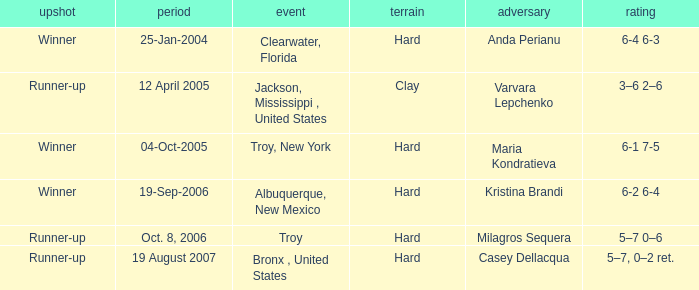What was the outcome of the game played on 19-Sep-2006? Winner. Help me parse the entirety of this table. {'header': ['upshot', 'period', 'event', 'terrain', 'adversary', 'rating'], 'rows': [['Winner', '25-Jan-2004', 'Clearwater, Florida', 'Hard', 'Anda Perianu', '6-4 6-3'], ['Runner-up', '12 April 2005', 'Jackson, Mississippi , United States', 'Clay', 'Varvara Lepchenko', '3–6 2–6'], ['Winner', '04-Oct-2005', 'Troy, New York', 'Hard', 'Maria Kondratieva', '6-1 7-5'], ['Winner', '19-Sep-2006', 'Albuquerque, New Mexico', 'Hard', 'Kristina Brandi', '6-2 6-4'], ['Runner-up', 'Oct. 8, 2006', 'Troy', 'Hard', 'Milagros Sequera', '5–7 0–6'], ['Runner-up', '19 August 2007', 'Bronx , United States', 'Hard', 'Casey Dellacqua', '5–7, 0–2 ret.']]} 